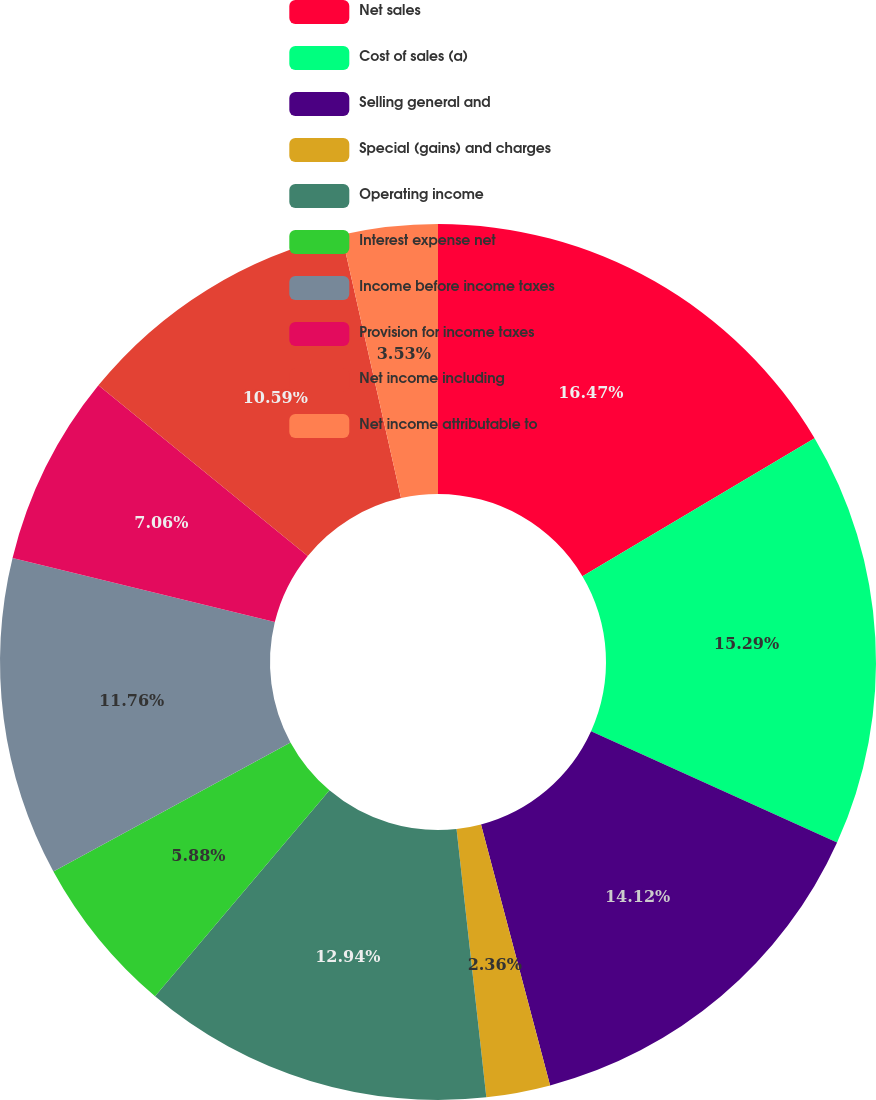<chart> <loc_0><loc_0><loc_500><loc_500><pie_chart><fcel>Net sales<fcel>Cost of sales (a)<fcel>Selling general and<fcel>Special (gains) and charges<fcel>Operating income<fcel>Interest expense net<fcel>Income before income taxes<fcel>Provision for income taxes<fcel>Net income including<fcel>Net income attributable to<nl><fcel>16.47%<fcel>15.29%<fcel>14.12%<fcel>2.36%<fcel>12.94%<fcel>5.88%<fcel>11.76%<fcel>7.06%<fcel>10.59%<fcel>3.53%<nl></chart> 